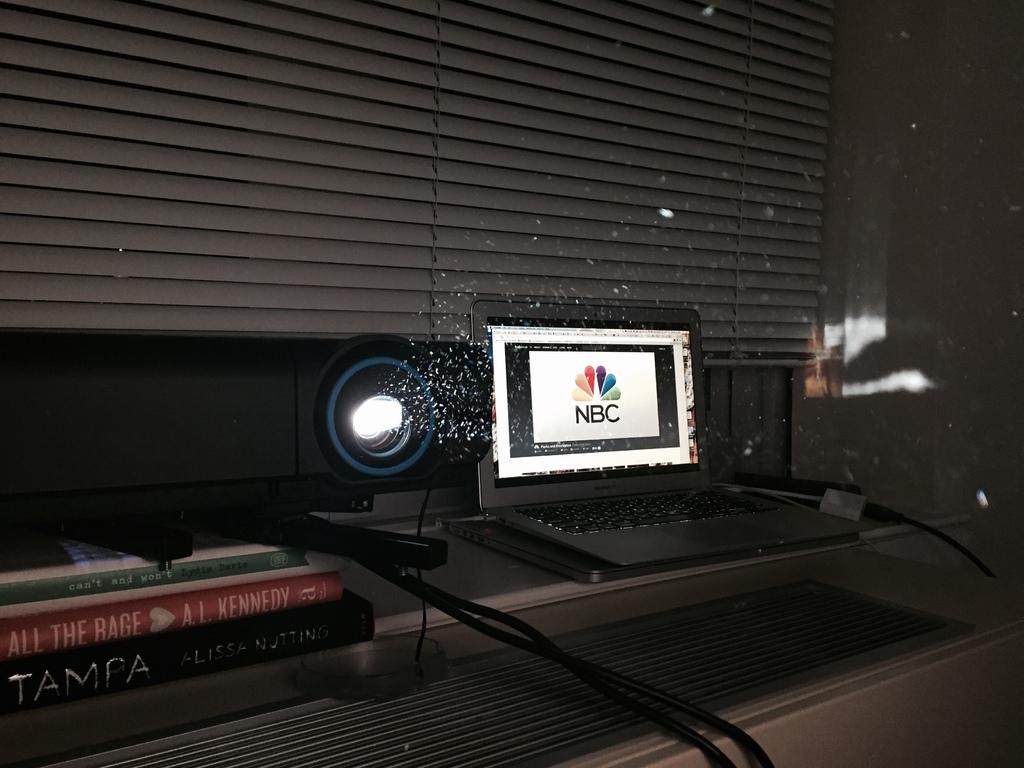What is the title of the second book?
Your response must be concise. All the rage. What is the production company?
Make the answer very short. Nbc. 